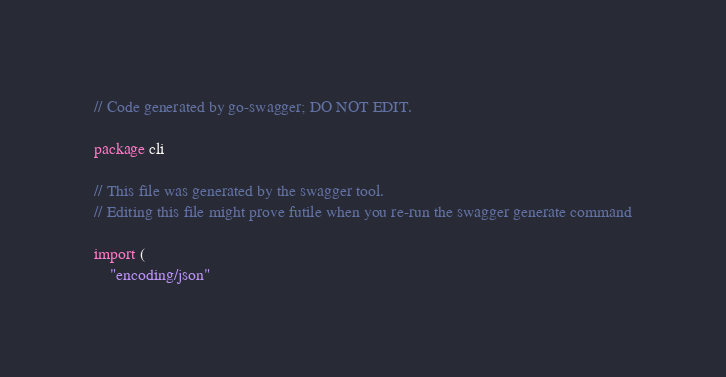<code> <loc_0><loc_0><loc_500><loc_500><_Go_>// Code generated by go-swagger; DO NOT EDIT.

package cli

// This file was generated by the swagger tool.
// Editing this file might prove futile when you re-run the swagger generate command

import (
	"encoding/json"</code> 